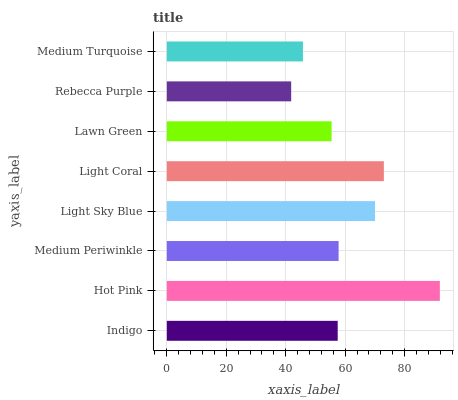Is Rebecca Purple the minimum?
Answer yes or no. Yes. Is Hot Pink the maximum?
Answer yes or no. Yes. Is Medium Periwinkle the minimum?
Answer yes or no. No. Is Medium Periwinkle the maximum?
Answer yes or no. No. Is Hot Pink greater than Medium Periwinkle?
Answer yes or no. Yes. Is Medium Periwinkle less than Hot Pink?
Answer yes or no. Yes. Is Medium Periwinkle greater than Hot Pink?
Answer yes or no. No. Is Hot Pink less than Medium Periwinkle?
Answer yes or no. No. Is Medium Periwinkle the high median?
Answer yes or no. Yes. Is Indigo the low median?
Answer yes or no. Yes. Is Lawn Green the high median?
Answer yes or no. No. Is Medium Turquoise the low median?
Answer yes or no. No. 